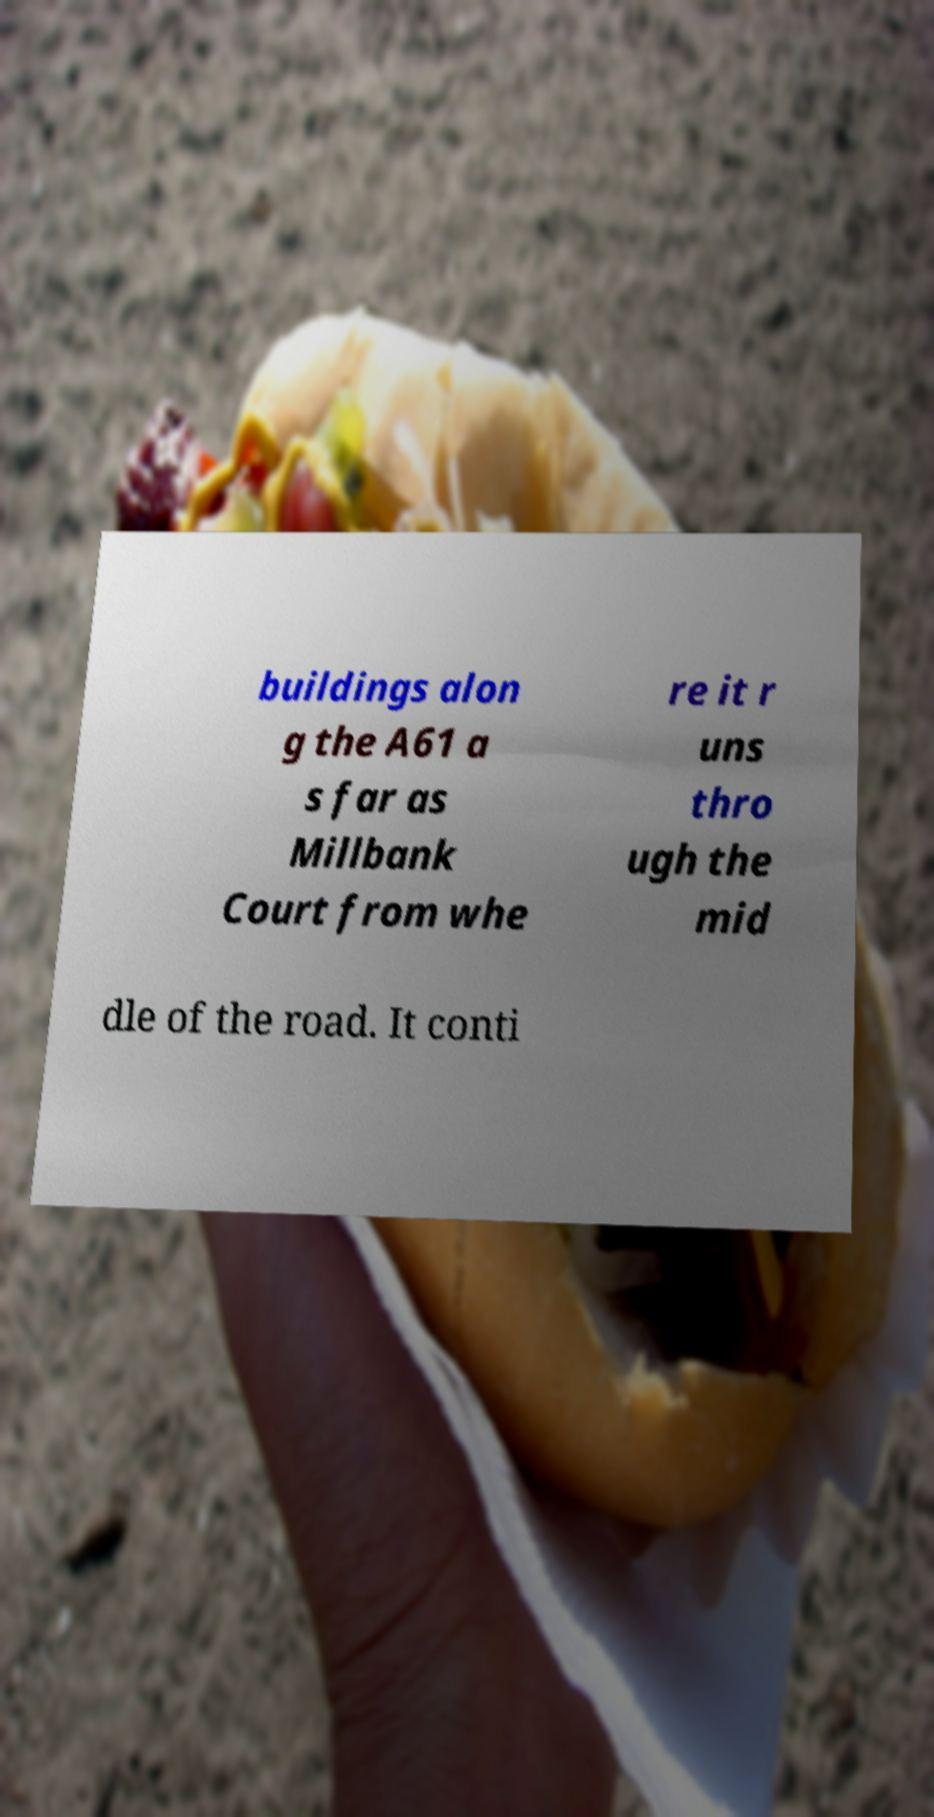There's text embedded in this image that I need extracted. Can you transcribe it verbatim? buildings alon g the A61 a s far as Millbank Court from whe re it r uns thro ugh the mid dle of the road. It conti 